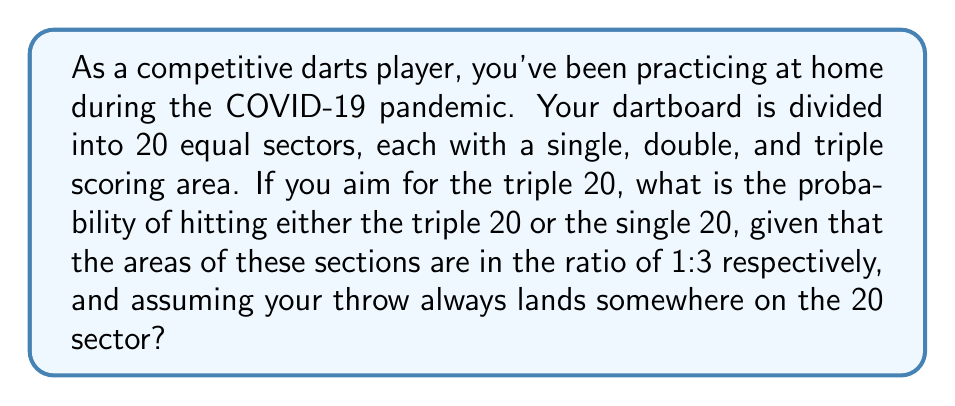Give your solution to this math problem. Let's approach this step-by-step:

1) First, we need to understand what the question is asking. We're looking for the probability of hitting either the triple 20 or the single 20, given that the throw lands somewhere in the 20 sector.

2) We're told that the areas of the triple 20 and single 20 are in the ratio of 1:3. This means:
   - If we denote the area of triple 20 as x, then the area of single 20 is 3x.
   - The total area we're considering (triple 20 + single 20) is x + 3x = 4x.

3) To calculate the probability, we use the formula:

   $$ P(event) = \frac{\text{favorable outcomes}}{\text{total possible outcomes}} $$

4) In this case:
   - Favorable outcomes: hitting either triple 20 (area x) or single 20 (area 3x)
   - Total possible outcomes: the entire area we're considering (4x)

5) Therefore, the probability is:

   $$ P(\text{triple 20 or single 20}) = \frac{x + 3x}{4x} = \frac{4x}{4x} = 1 $$

6) This makes sense intuitively as well. If we're guaranteed to hit the 20 sector, and we're only considering the triple and single areas within that sector, we must hit one of them.
Answer: The probability of hitting either the triple 20 or the single 20, given that the throw lands in the 20 sector, is 1 or 100%. 